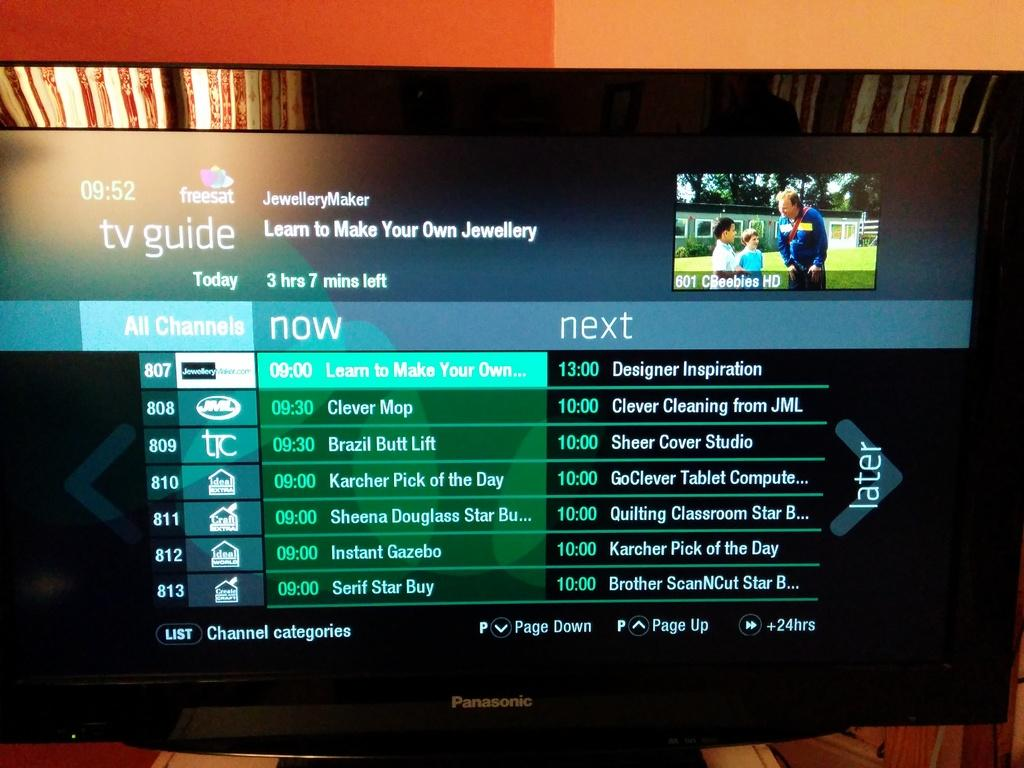<image>
Provide a brief description of the given image. A Panasonic TV tuned into the TV Guide channel. 